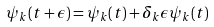<formula> <loc_0><loc_0><loc_500><loc_500>\psi _ { k } ( t + \epsilon ) = \psi _ { k } ( t ) + \delta _ { k } \epsilon \psi _ { k } ( t )</formula> 